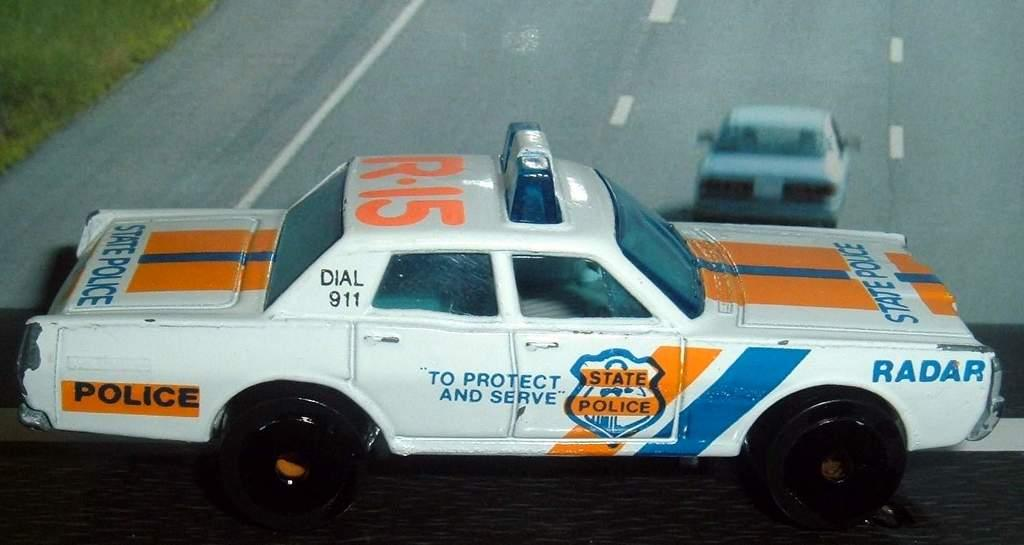What is the main subject of the image? The main subject of the image is a car with text and numbers. Are there any other cars visible in the image? Yes, there is another car visible on the road in the image. What type of vegetation can be seen in the image? There is grass in the image. What type of care can be seen on the tongue of the person in the image? There is no person or tongue present in the image, so it is not possible to answer that question. 